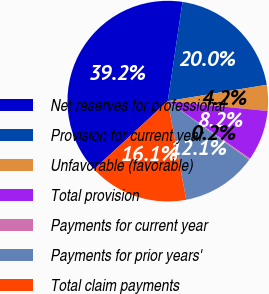Convert chart. <chart><loc_0><loc_0><loc_500><loc_500><pie_chart><fcel>Net reserves for professional<fcel>Provision for current year<fcel>Unfavorable (favorable)<fcel>Total provision<fcel>Payments for current year<fcel>Payments for prior years'<fcel>Total claim payments<nl><fcel>39.21%<fcel>20.04%<fcel>4.18%<fcel>8.15%<fcel>0.22%<fcel>12.11%<fcel>16.08%<nl></chart> 